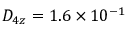<formula> <loc_0><loc_0><loc_500><loc_500>D _ { 4 z } = 1 . 6 \times 1 0 ^ { - 1 }</formula> 